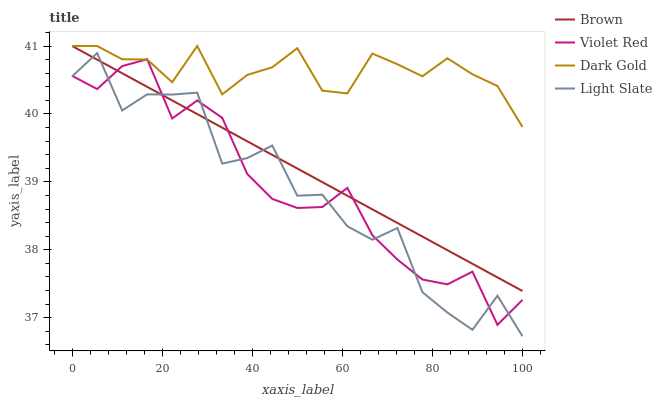Does Light Slate have the minimum area under the curve?
Answer yes or no. Yes. Does Dark Gold have the maximum area under the curve?
Answer yes or no. Yes. Does Brown have the minimum area under the curve?
Answer yes or no. No. Does Brown have the maximum area under the curve?
Answer yes or no. No. Is Brown the smoothest?
Answer yes or no. Yes. Is Light Slate the roughest?
Answer yes or no. Yes. Is Violet Red the smoothest?
Answer yes or no. No. Is Violet Red the roughest?
Answer yes or no. No. Does Light Slate have the lowest value?
Answer yes or no. Yes. Does Brown have the lowest value?
Answer yes or no. No. Does Dark Gold have the highest value?
Answer yes or no. Yes. Does Violet Red have the highest value?
Answer yes or no. No. Is Light Slate less than Dark Gold?
Answer yes or no. Yes. Is Dark Gold greater than Light Slate?
Answer yes or no. Yes. Does Violet Red intersect Brown?
Answer yes or no. Yes. Is Violet Red less than Brown?
Answer yes or no. No. Is Violet Red greater than Brown?
Answer yes or no. No. Does Light Slate intersect Dark Gold?
Answer yes or no. No. 